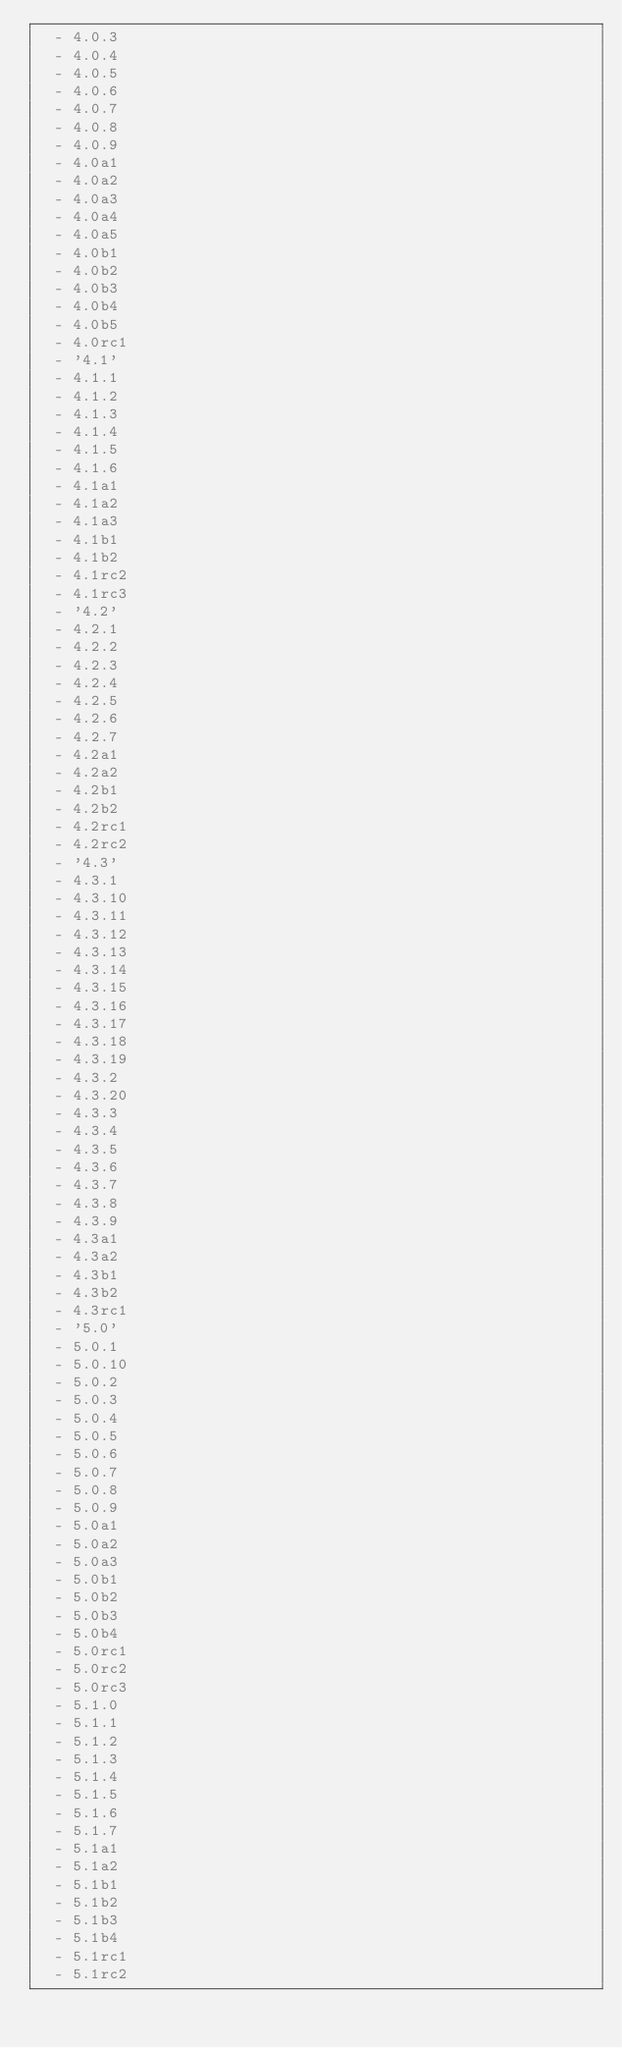Convert code to text. <code><loc_0><loc_0><loc_500><loc_500><_YAML_>  - 4.0.3
  - 4.0.4
  - 4.0.5
  - 4.0.6
  - 4.0.7
  - 4.0.8
  - 4.0.9
  - 4.0a1
  - 4.0a2
  - 4.0a3
  - 4.0a4
  - 4.0a5
  - 4.0b1
  - 4.0b2
  - 4.0b3
  - 4.0b4
  - 4.0b5
  - 4.0rc1
  - '4.1'
  - 4.1.1
  - 4.1.2
  - 4.1.3
  - 4.1.4
  - 4.1.5
  - 4.1.6
  - 4.1a1
  - 4.1a2
  - 4.1a3
  - 4.1b1
  - 4.1b2
  - 4.1rc2
  - 4.1rc3
  - '4.2'
  - 4.2.1
  - 4.2.2
  - 4.2.3
  - 4.2.4
  - 4.2.5
  - 4.2.6
  - 4.2.7
  - 4.2a1
  - 4.2a2
  - 4.2b1
  - 4.2b2
  - 4.2rc1
  - 4.2rc2
  - '4.3'
  - 4.3.1
  - 4.3.10
  - 4.3.11
  - 4.3.12
  - 4.3.13
  - 4.3.14
  - 4.3.15
  - 4.3.16
  - 4.3.17
  - 4.3.18
  - 4.3.19
  - 4.3.2
  - 4.3.20
  - 4.3.3
  - 4.3.4
  - 4.3.5
  - 4.3.6
  - 4.3.7
  - 4.3.8
  - 4.3.9
  - 4.3a1
  - 4.3a2
  - 4.3b1
  - 4.3b2
  - 4.3rc1
  - '5.0'
  - 5.0.1
  - 5.0.10
  - 5.0.2
  - 5.0.3
  - 5.0.4
  - 5.0.5
  - 5.0.6
  - 5.0.7
  - 5.0.8
  - 5.0.9
  - 5.0a1
  - 5.0a2
  - 5.0a3
  - 5.0b1
  - 5.0b2
  - 5.0b3
  - 5.0b4
  - 5.0rc1
  - 5.0rc2
  - 5.0rc3
  - 5.1.0
  - 5.1.1
  - 5.1.2
  - 5.1.3
  - 5.1.4
  - 5.1.5
  - 5.1.6
  - 5.1.7
  - 5.1a1
  - 5.1a2
  - 5.1b1
  - 5.1b2
  - 5.1b3
  - 5.1b4
  - 5.1rc1
  - 5.1rc2</code> 